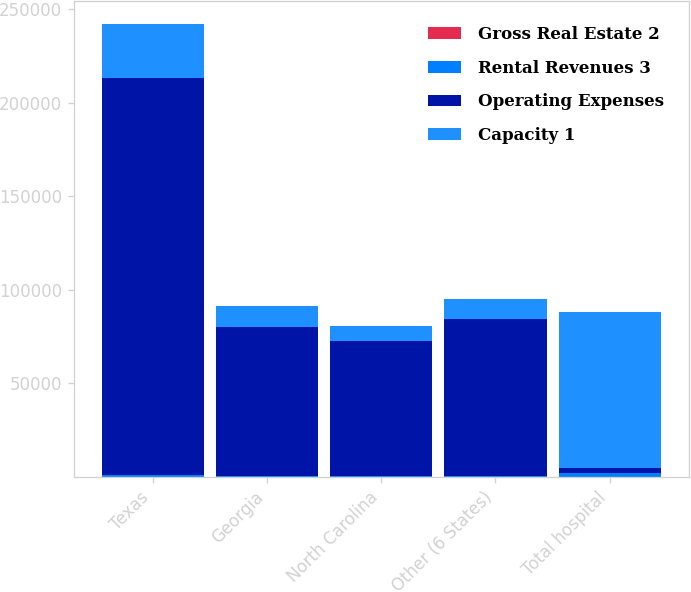Convert chart to OTSL. <chart><loc_0><loc_0><loc_500><loc_500><stacked_bar_chart><ecel><fcel>Texas<fcel>Georgia<fcel>North Carolina<fcel>Other (6 States)<fcel>Total hospital<nl><fcel>Gross Real Estate 2<fcel>4<fcel>2<fcel>1<fcel>7<fcel>17<nl><fcel>Rental Revenues 3<fcel>959<fcel>274<fcel>355<fcel>405<fcel>2368<nl><fcel>Operating Expenses<fcel>212034<fcel>79749<fcel>72500<fcel>83959<fcel>2368<nl><fcel>Capacity 1<fcel>29160<fcel>11481<fcel>7789<fcel>10459<fcel>83491<nl></chart> 